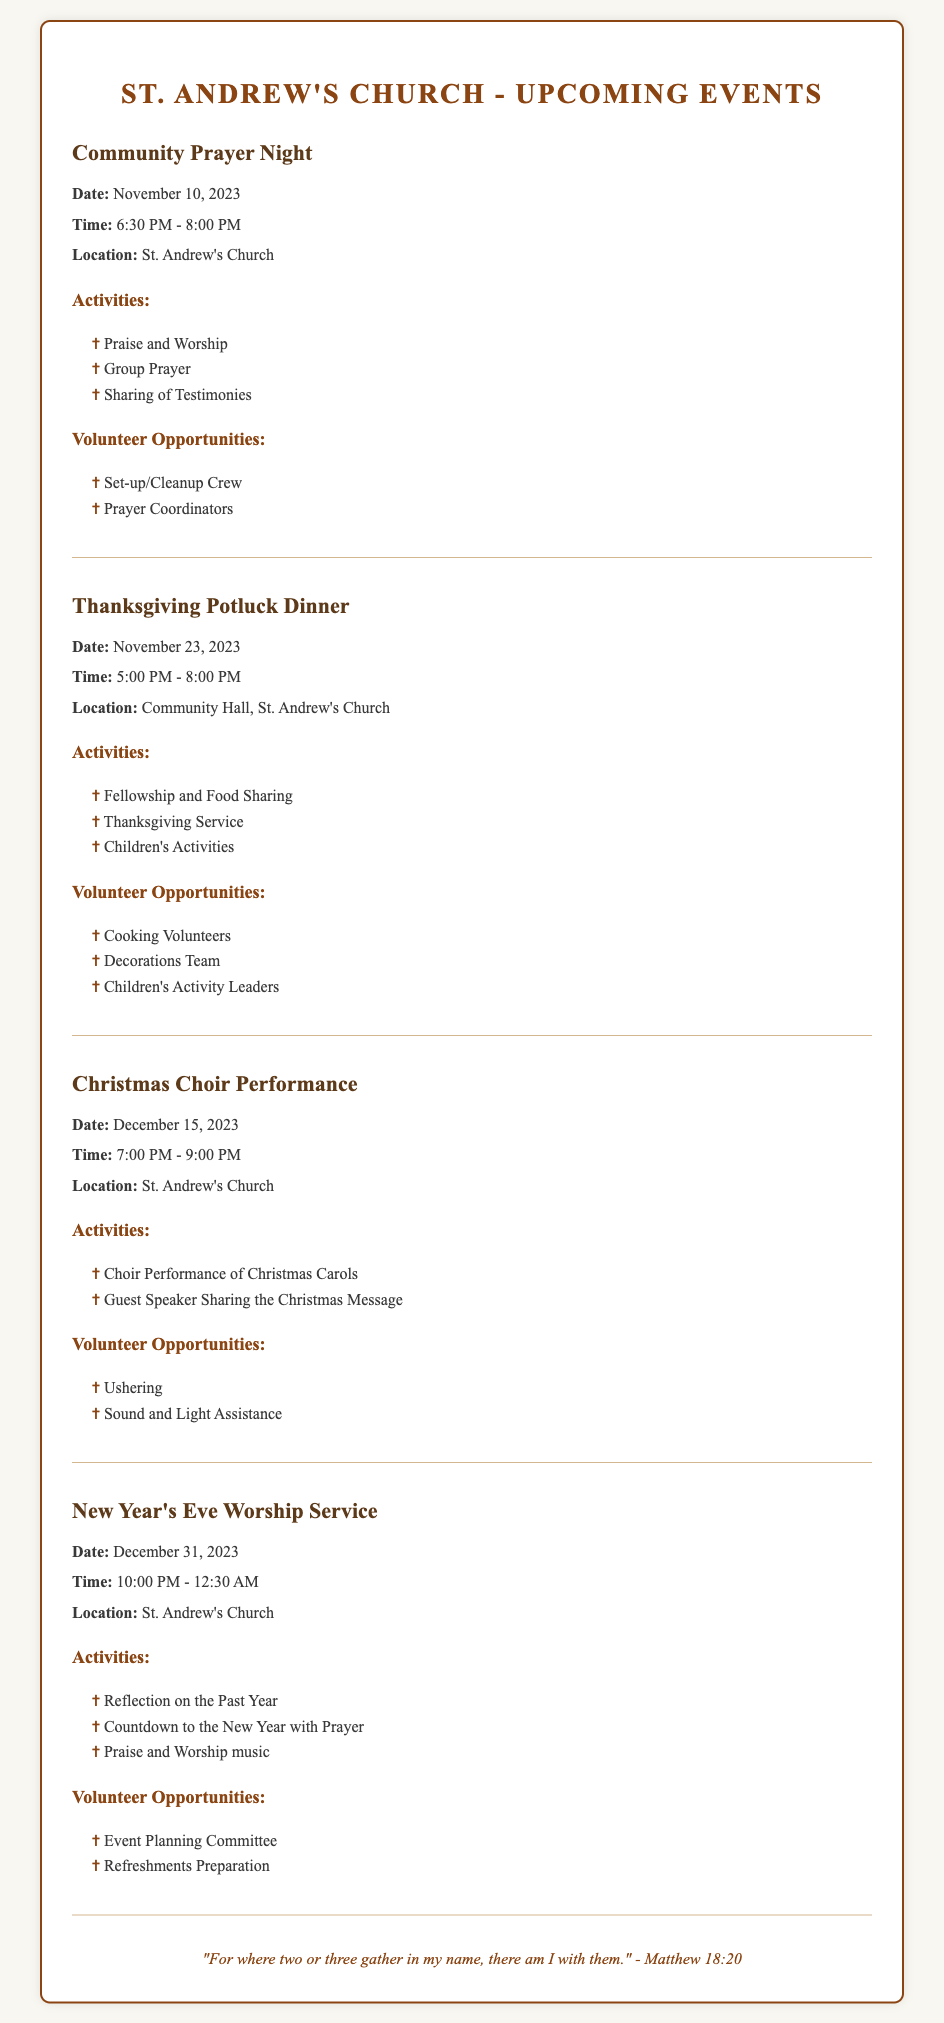What is the date of the Community Prayer Night? The date for the Community Prayer Night is provided in the document as November 10, 2023.
Answer: November 10, 2023 What activity is included in the Thanksgiving Potluck Dinner? One of the activities listed for the Thanksgiving Potluck Dinner is "Thanksgiving Service," which is mentioned under the activities section.
Answer: Thanksgiving Service How many volunteer opportunities are listed for the Christmas Choir Performance? The document outlines two volunteer opportunities for the Christmas Choir Performance, which are listed in the volunteer section.
Answer: 2 What time does the New Year's Eve Worship Service start? The starting time for the New Year's Eve Worship Service is indicated in the document as 10:00 PM.
Answer: 10:00 PM Which event includes a Guest Speaker? The event that includes a Guest Speaker, as mentioned in the activities section, is the Christmas Choir Performance.
Answer: Christmas Choir Performance What is the overall theme of the activities during the Community Prayer Night? The activities during the Community Prayer Night center around Praise and Worship, Group Prayer, and Sharing of Testimonies, emphasizing community faith and support.
Answer: Praise and Worship Where will the Thanksgiving Potluck Dinner be held? The location for the Thanksgiving Potluck Dinner is specified in the document as the Community Hall, St. Andrew's Church.
Answer: Community Hall, St. Andrew's Church 